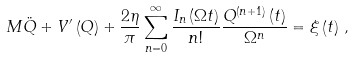<formula> <loc_0><loc_0><loc_500><loc_500>M \ddot { Q } + { V } ^ { \prime } \left ( Q \right ) + \frac { 2 \eta } { \pi } \sum ^ { \infty } _ { n = 0 } \frac { I _ { n } \left ( \Omega t \right ) } { n ! } \frac { Q ^ { ( n + 1 ) } \left ( t \right ) } { \Omega ^ { n } } = \xi \left ( t \right ) \, ,</formula> 